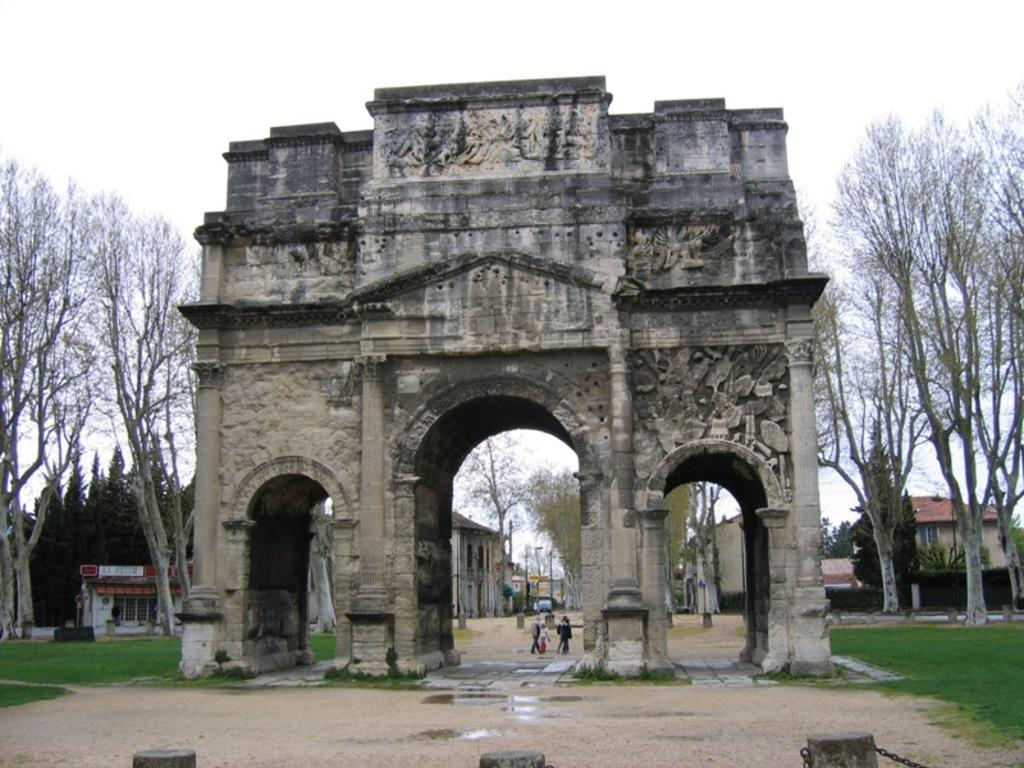What type of structures can be seen in the image? There are buildings in the image. What other natural elements are present in the image? There are trees in the image. What are the people in the image doing? There are people walking in the image. What type of ground cover is visible in the image? There is grass on the ground in the image. What architectural feature can be seen in the image? There appears to be an arch in the image. What is visible in the background of the image? The sky is visible in the image. What type of hammer is being used to construct the building in the image? There is no hammer present in the image; it shows people walking and buildings, but no construction activity. What type of beam is supporting the arch in the image? There is no beam visible in the image; only the arch itself is present. 